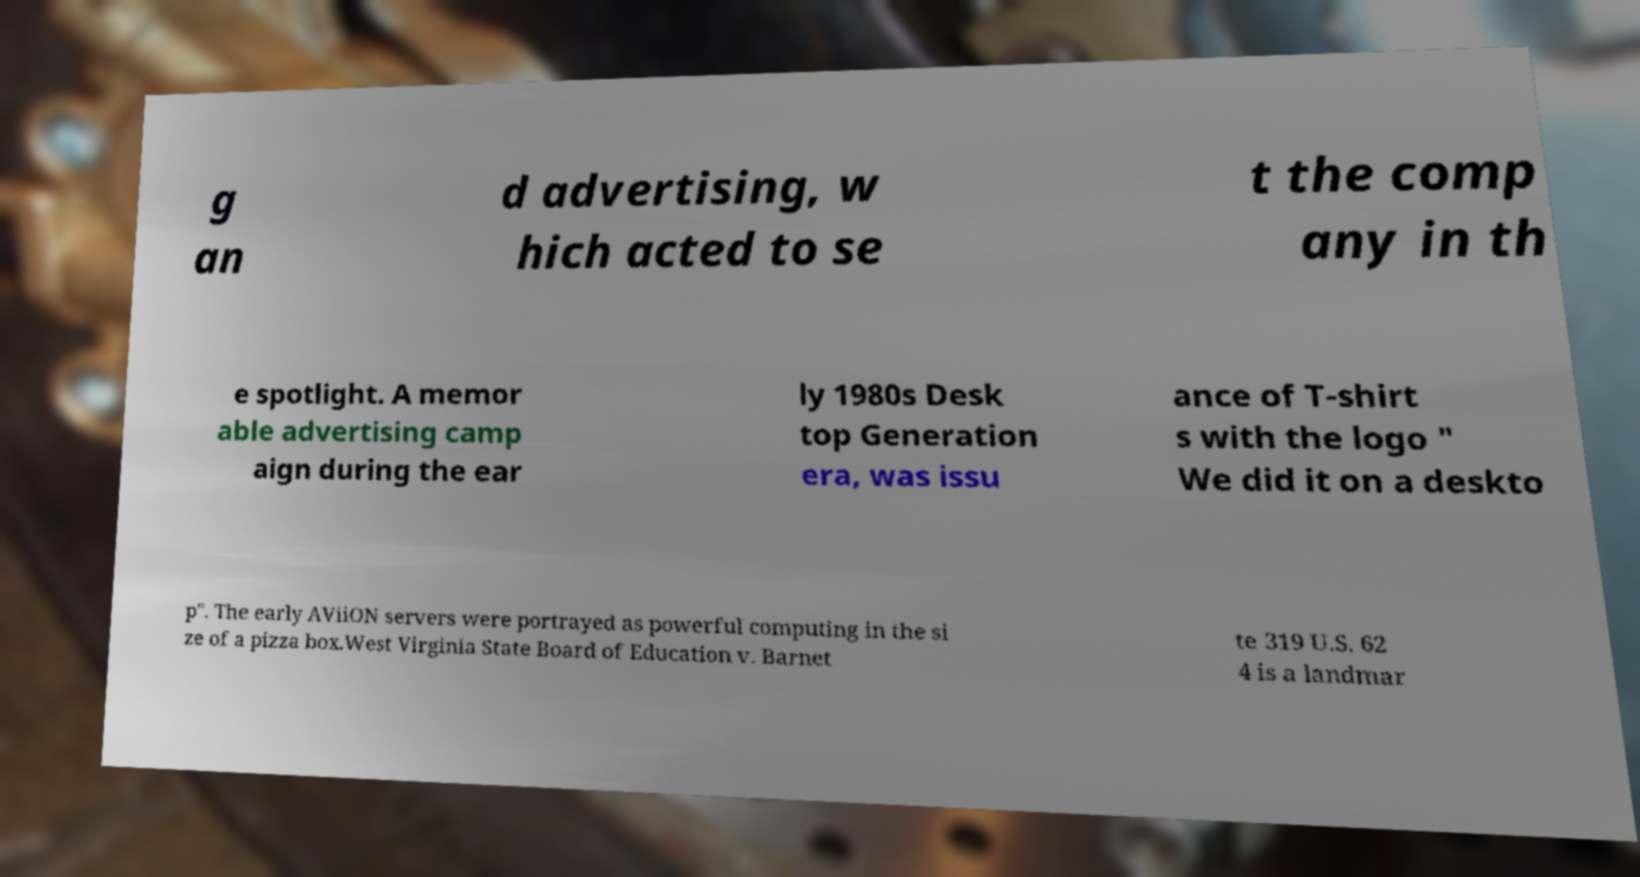Can you read and provide the text displayed in the image?This photo seems to have some interesting text. Can you extract and type it out for me? g an d advertising, w hich acted to se t the comp any in th e spotlight. A memor able advertising camp aign during the ear ly 1980s Desk top Generation era, was issu ance of T-shirt s with the logo " We did it on a deskto p". The early AViiON servers were portrayed as powerful computing in the si ze of a pizza box.West Virginia State Board of Education v. Barnet te 319 U.S. 62 4 is a landmar 